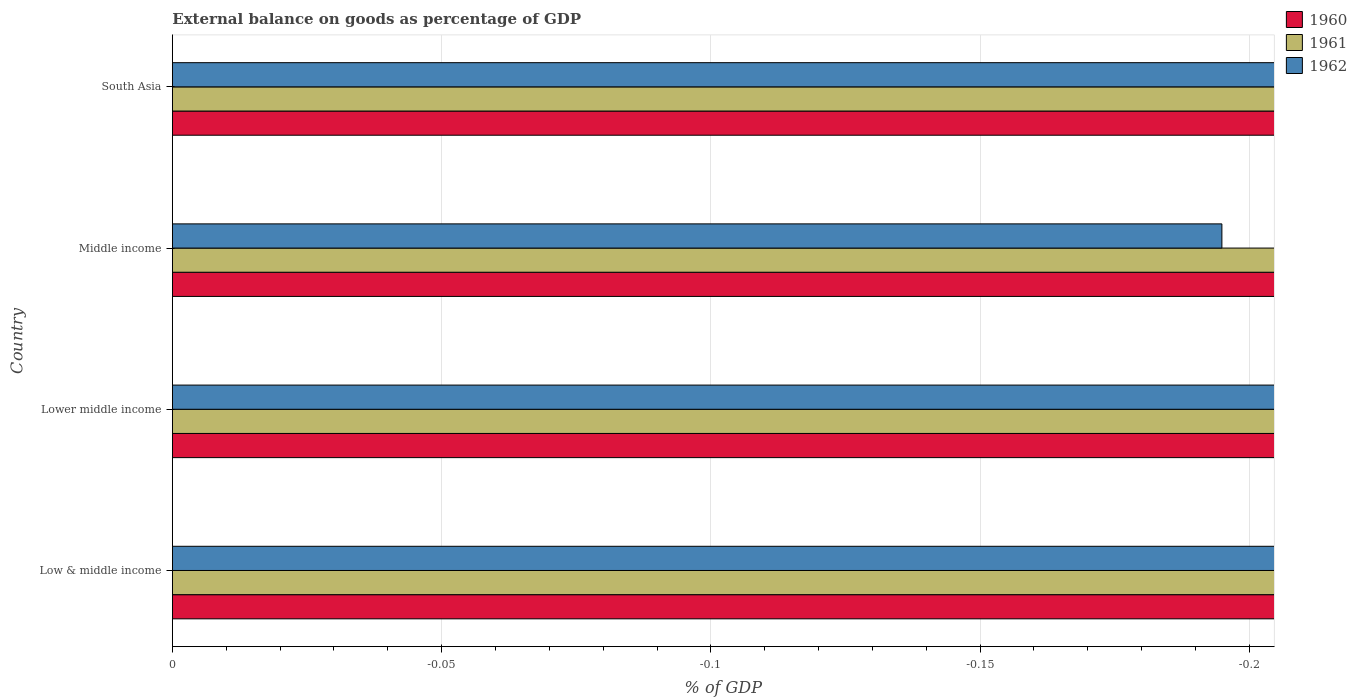Are the number of bars per tick equal to the number of legend labels?
Give a very brief answer. No. How many bars are there on the 4th tick from the bottom?
Your answer should be very brief. 0. In how many cases, is the number of bars for a given country not equal to the number of legend labels?
Your answer should be compact. 4. What is the difference between the external balance on goods as percentage of GDP in 1960 in South Asia and the external balance on goods as percentage of GDP in 1962 in Low & middle income?
Ensure brevity in your answer.  0. Is it the case that in every country, the sum of the external balance on goods as percentage of GDP in 1961 and external balance on goods as percentage of GDP in 1960 is greater than the external balance on goods as percentage of GDP in 1962?
Offer a terse response. No. How many bars are there?
Offer a very short reply. 0. Are all the bars in the graph horizontal?
Your response must be concise. Yes. How many countries are there in the graph?
Keep it short and to the point. 4. What is the difference between two consecutive major ticks on the X-axis?
Provide a succinct answer. 0.05. Are the values on the major ticks of X-axis written in scientific E-notation?
Provide a succinct answer. No. Does the graph contain any zero values?
Keep it short and to the point. Yes. Does the graph contain grids?
Give a very brief answer. Yes. What is the title of the graph?
Offer a very short reply. External balance on goods as percentage of GDP. What is the label or title of the X-axis?
Your answer should be compact. % of GDP. What is the % of GDP of 1961 in Lower middle income?
Provide a succinct answer. 0. What is the % of GDP in 1961 in Middle income?
Keep it short and to the point. 0. What is the % of GDP of 1962 in Middle income?
Make the answer very short. 0. What is the % of GDP of 1960 in South Asia?
Your answer should be very brief. 0. What is the total % of GDP of 1960 in the graph?
Make the answer very short. 0. What is the total % of GDP in 1961 in the graph?
Give a very brief answer. 0. What is the average % of GDP of 1960 per country?
Your answer should be very brief. 0. What is the average % of GDP in 1961 per country?
Your answer should be compact. 0. What is the average % of GDP in 1962 per country?
Provide a succinct answer. 0. 